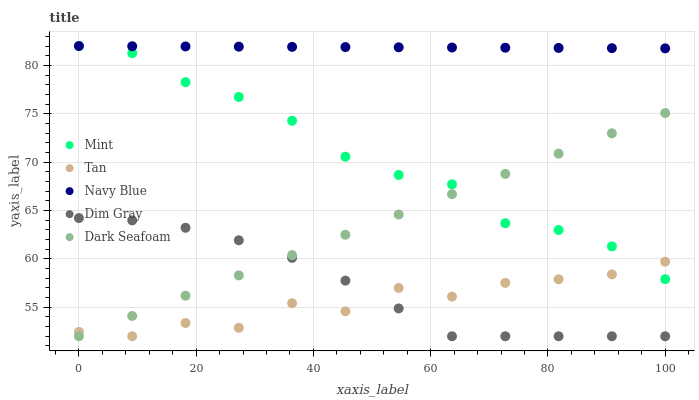Does Tan have the minimum area under the curve?
Answer yes or no. Yes. Does Navy Blue have the maximum area under the curve?
Answer yes or no. Yes. Does Dim Gray have the minimum area under the curve?
Answer yes or no. No. Does Dim Gray have the maximum area under the curve?
Answer yes or no. No. Is Dark Seafoam the smoothest?
Answer yes or no. Yes. Is Tan the roughest?
Answer yes or no. Yes. Is Dim Gray the smoothest?
Answer yes or no. No. Is Dim Gray the roughest?
Answer yes or no. No. Does Tan have the lowest value?
Answer yes or no. Yes. Does Mint have the lowest value?
Answer yes or no. No. Does Mint have the highest value?
Answer yes or no. Yes. Does Dim Gray have the highest value?
Answer yes or no. No. Is Tan less than Navy Blue?
Answer yes or no. Yes. Is Navy Blue greater than Dark Seafoam?
Answer yes or no. Yes. Does Mint intersect Dark Seafoam?
Answer yes or no. Yes. Is Mint less than Dark Seafoam?
Answer yes or no. No. Is Mint greater than Dark Seafoam?
Answer yes or no. No. Does Tan intersect Navy Blue?
Answer yes or no. No. 